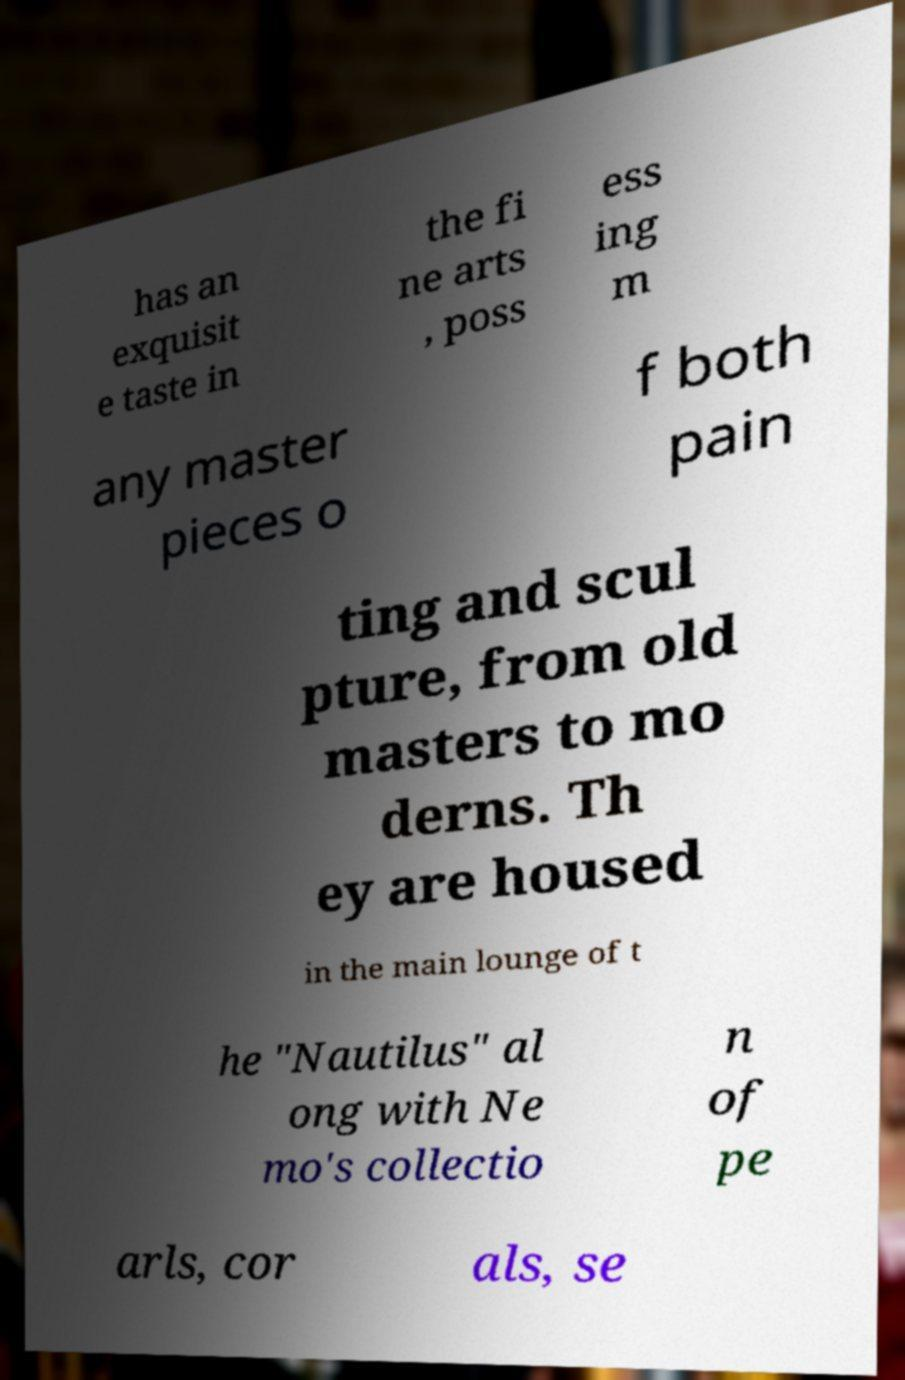Please identify and transcribe the text found in this image. has an exquisit e taste in the fi ne arts , poss ess ing m any master pieces o f both pain ting and scul pture, from old masters to mo derns. Th ey are housed in the main lounge of t he "Nautilus" al ong with Ne mo's collectio n of pe arls, cor als, se 